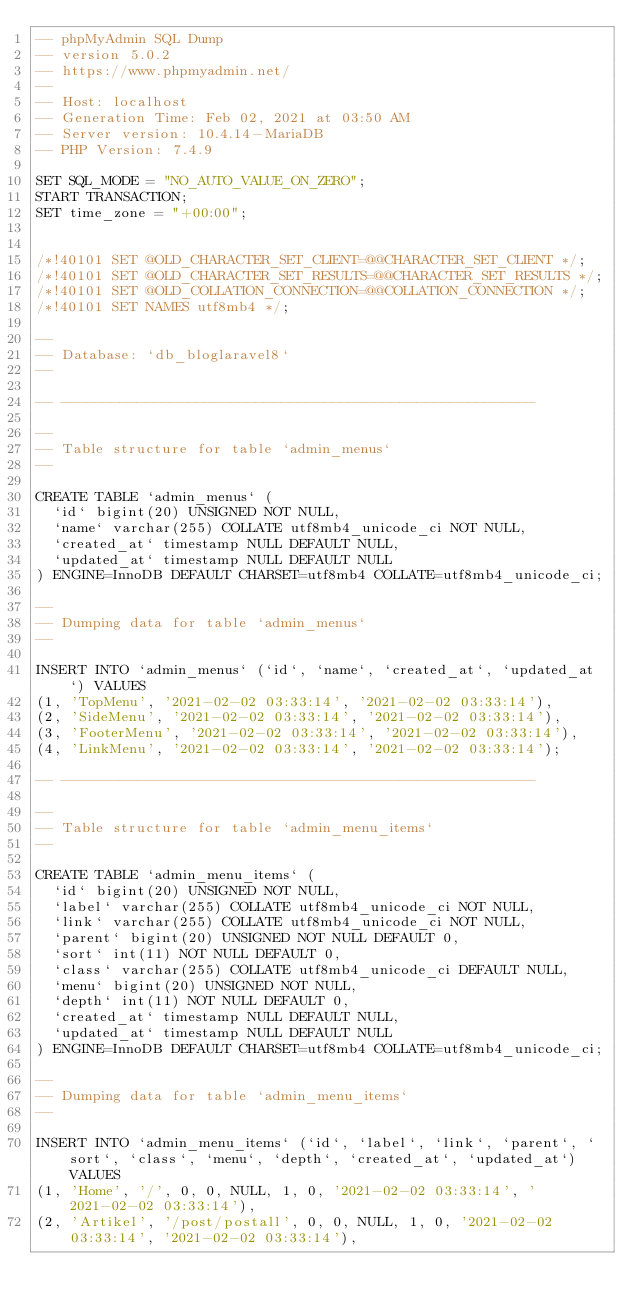<code> <loc_0><loc_0><loc_500><loc_500><_SQL_>-- phpMyAdmin SQL Dump
-- version 5.0.2
-- https://www.phpmyadmin.net/
--
-- Host: localhost
-- Generation Time: Feb 02, 2021 at 03:50 AM
-- Server version: 10.4.14-MariaDB
-- PHP Version: 7.4.9

SET SQL_MODE = "NO_AUTO_VALUE_ON_ZERO";
START TRANSACTION;
SET time_zone = "+00:00";


/*!40101 SET @OLD_CHARACTER_SET_CLIENT=@@CHARACTER_SET_CLIENT */;
/*!40101 SET @OLD_CHARACTER_SET_RESULTS=@@CHARACTER_SET_RESULTS */;
/*!40101 SET @OLD_COLLATION_CONNECTION=@@COLLATION_CONNECTION */;
/*!40101 SET NAMES utf8mb4 */;

--
-- Database: `db_bloglaravel8`
--

-- --------------------------------------------------------

--
-- Table structure for table `admin_menus`
--

CREATE TABLE `admin_menus` (
  `id` bigint(20) UNSIGNED NOT NULL,
  `name` varchar(255) COLLATE utf8mb4_unicode_ci NOT NULL,
  `created_at` timestamp NULL DEFAULT NULL,
  `updated_at` timestamp NULL DEFAULT NULL
) ENGINE=InnoDB DEFAULT CHARSET=utf8mb4 COLLATE=utf8mb4_unicode_ci;

--
-- Dumping data for table `admin_menus`
--

INSERT INTO `admin_menus` (`id`, `name`, `created_at`, `updated_at`) VALUES
(1, 'TopMenu', '2021-02-02 03:33:14', '2021-02-02 03:33:14'),
(2, 'SideMenu', '2021-02-02 03:33:14', '2021-02-02 03:33:14'),
(3, 'FooterMenu', '2021-02-02 03:33:14', '2021-02-02 03:33:14'),
(4, 'LinkMenu', '2021-02-02 03:33:14', '2021-02-02 03:33:14');

-- --------------------------------------------------------

--
-- Table structure for table `admin_menu_items`
--

CREATE TABLE `admin_menu_items` (
  `id` bigint(20) UNSIGNED NOT NULL,
  `label` varchar(255) COLLATE utf8mb4_unicode_ci NOT NULL,
  `link` varchar(255) COLLATE utf8mb4_unicode_ci NOT NULL,
  `parent` bigint(20) UNSIGNED NOT NULL DEFAULT 0,
  `sort` int(11) NOT NULL DEFAULT 0,
  `class` varchar(255) COLLATE utf8mb4_unicode_ci DEFAULT NULL,
  `menu` bigint(20) UNSIGNED NOT NULL,
  `depth` int(11) NOT NULL DEFAULT 0,
  `created_at` timestamp NULL DEFAULT NULL,
  `updated_at` timestamp NULL DEFAULT NULL
) ENGINE=InnoDB DEFAULT CHARSET=utf8mb4 COLLATE=utf8mb4_unicode_ci;

--
-- Dumping data for table `admin_menu_items`
--

INSERT INTO `admin_menu_items` (`id`, `label`, `link`, `parent`, `sort`, `class`, `menu`, `depth`, `created_at`, `updated_at`) VALUES
(1, 'Home', '/', 0, 0, NULL, 1, 0, '2021-02-02 03:33:14', '2021-02-02 03:33:14'),
(2, 'Artikel', '/post/postall', 0, 0, NULL, 1, 0, '2021-02-02 03:33:14', '2021-02-02 03:33:14'),</code> 